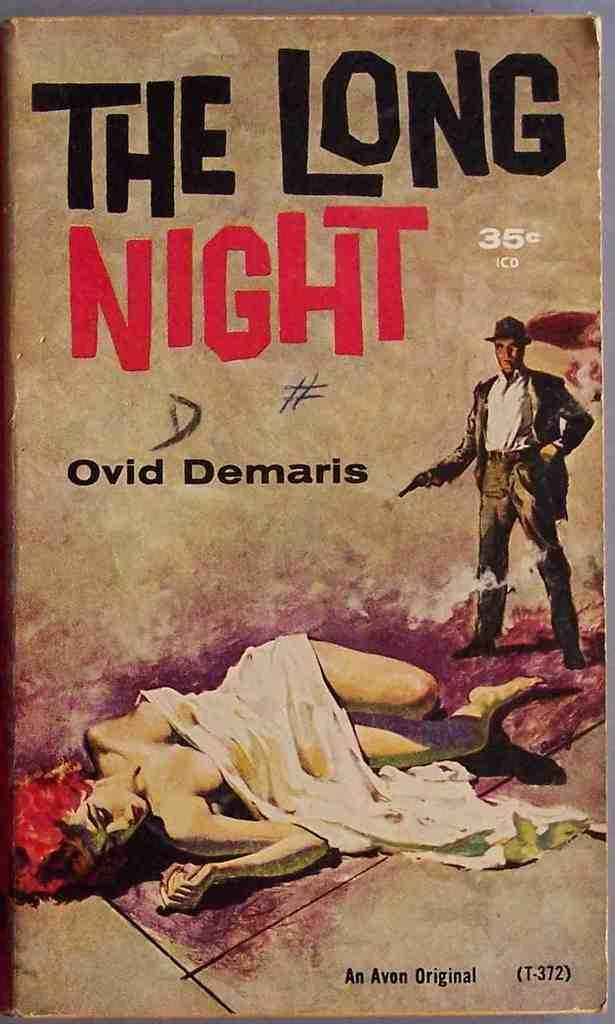<image>
Provide a brief description of the given image. A picture of a book titled the long night. 